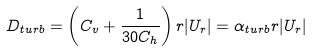Convert formula to latex. <formula><loc_0><loc_0><loc_500><loc_500>D _ { t u r b } = \left ( C _ { v } + \frac { 1 } { 3 0 C _ { h } } \right ) r | U _ { r } | = \alpha _ { t u r b } r | U _ { r } |</formula> 